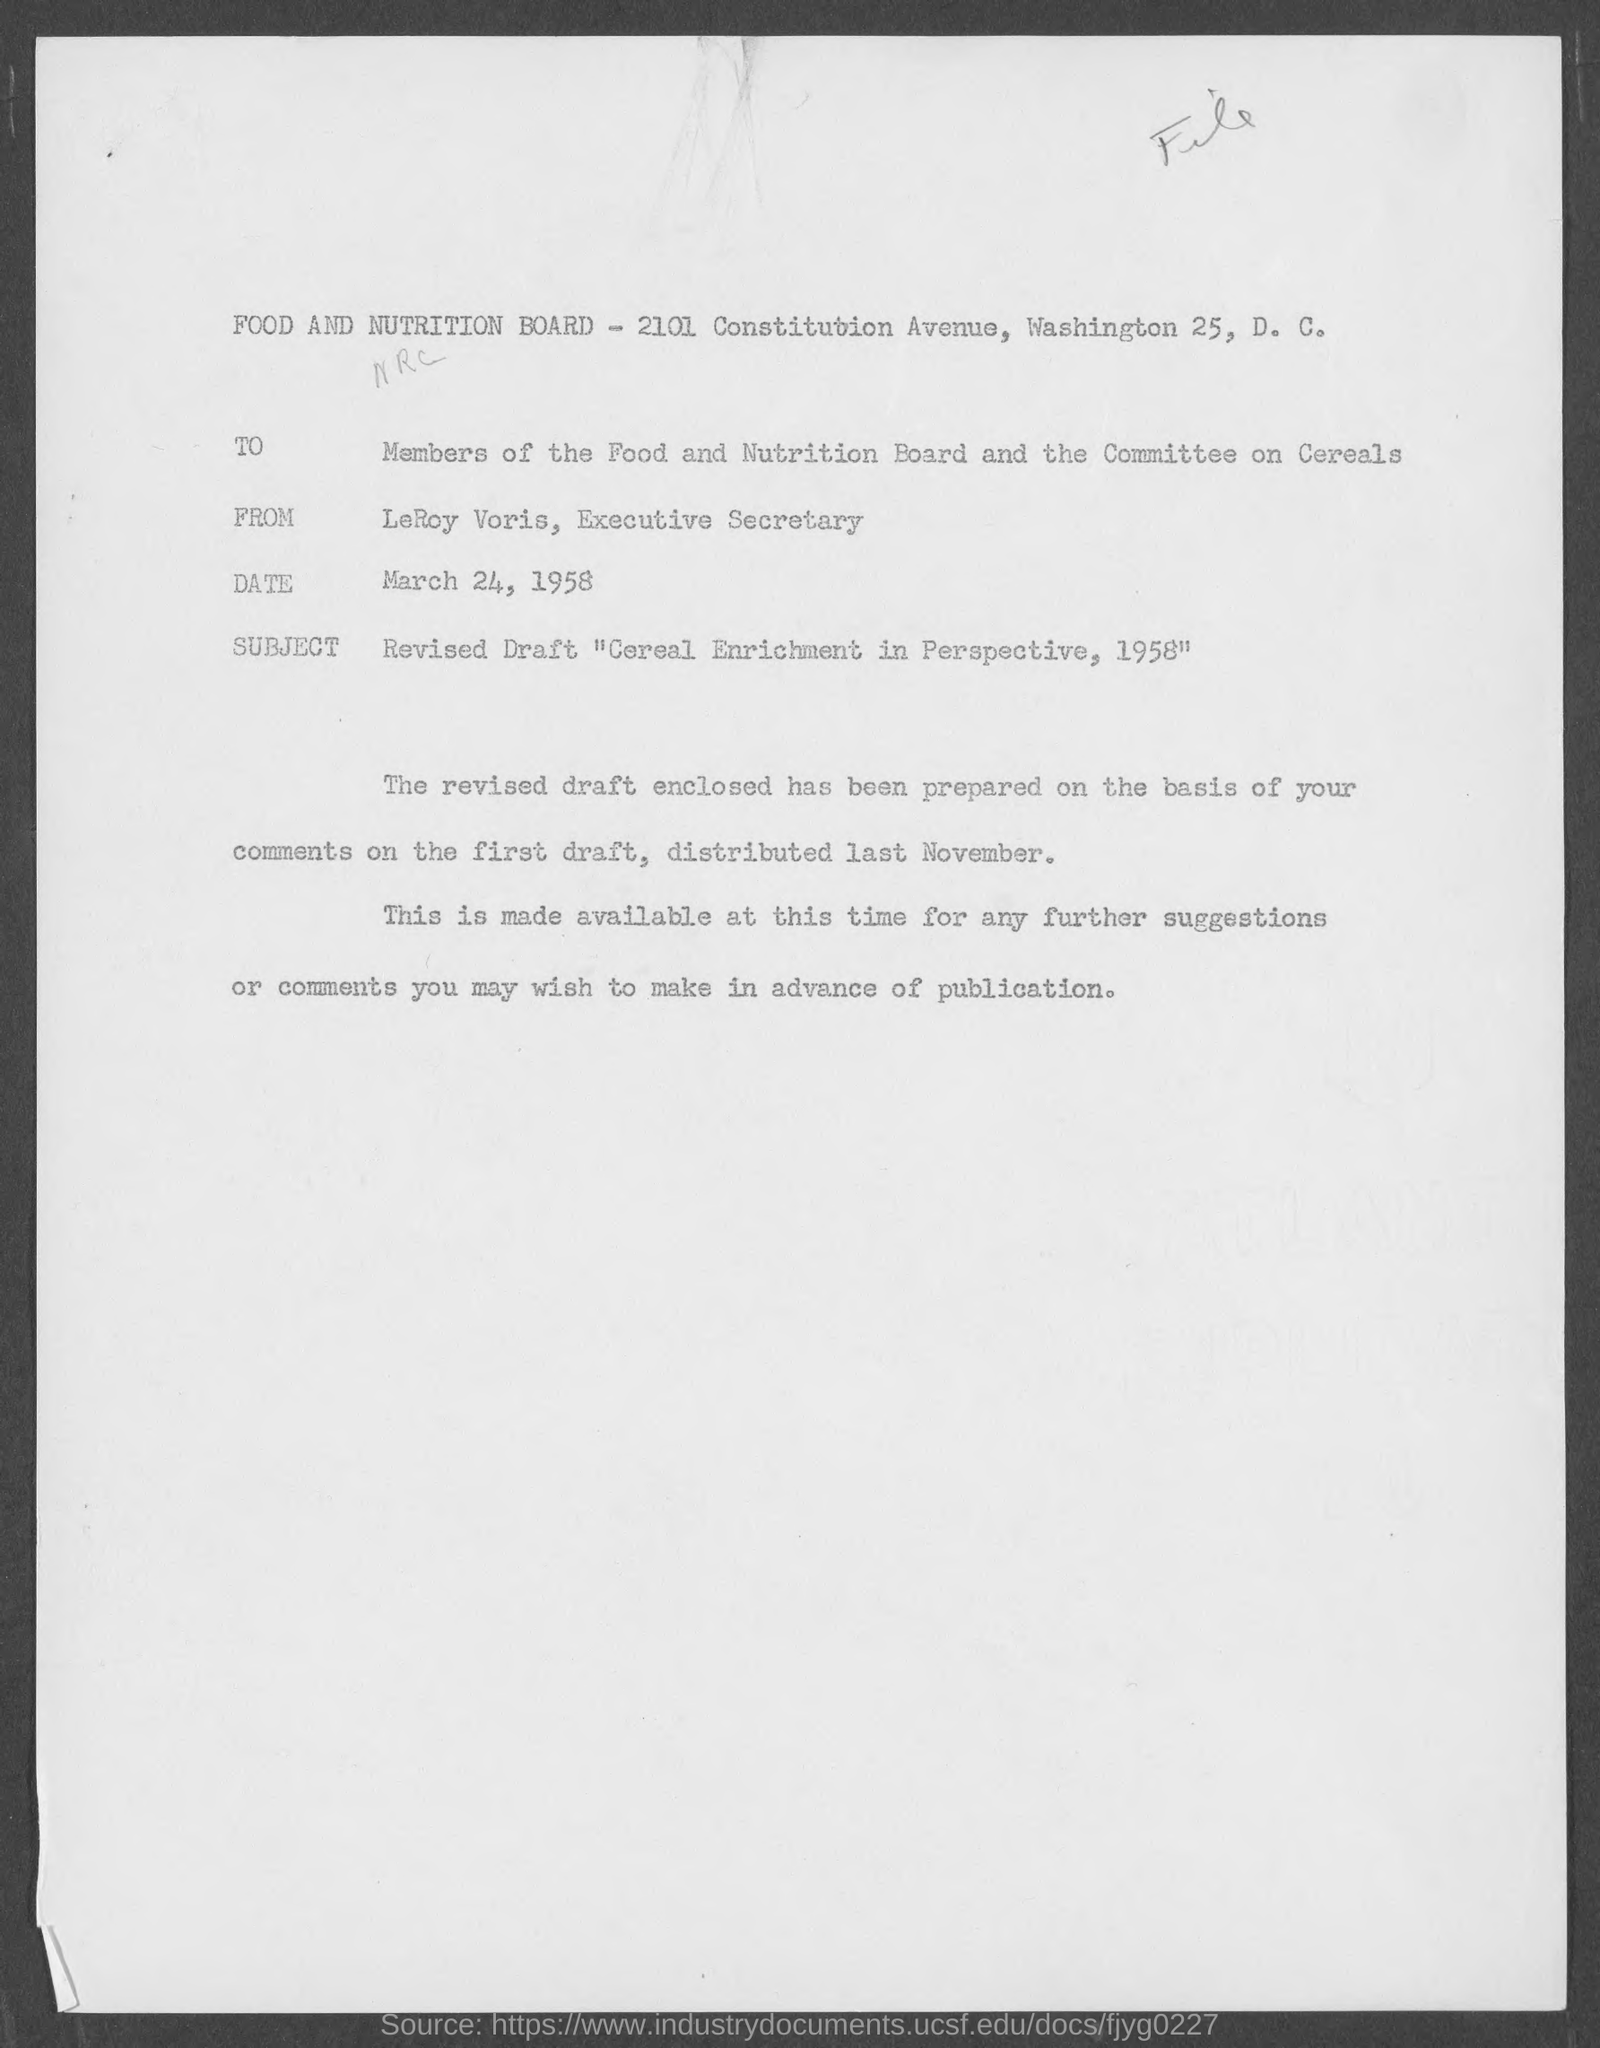Highlight a few significant elements in this photo. LeRoy Voris holds the position of Executive Secretary. The subject of the memorandum is "Revised Draft 'Cereal Enrichment in Perspective, 1958'. The memorandum is dated March 24, 1958. 